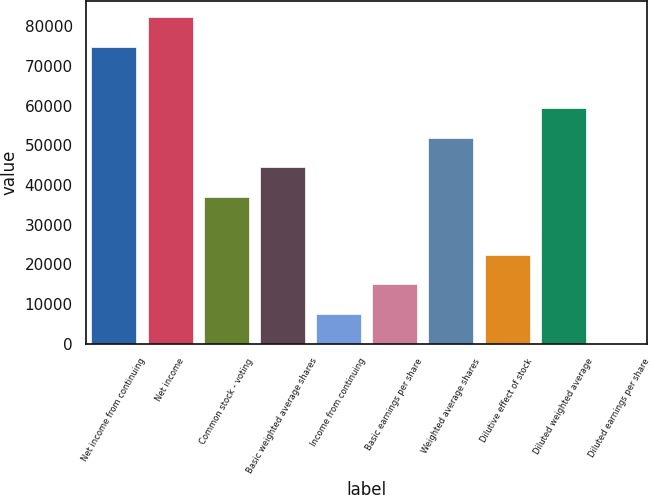<chart> <loc_0><loc_0><loc_500><loc_500><bar_chart><fcel>Net income from continuing<fcel>Net income<fcel>Common stock - voting<fcel>Basic weighted average shares<fcel>Income from continuing<fcel>Basic earnings per share<fcel>Weighted average shares<fcel>Dilutive effect of stock<fcel>Diluted weighted average<fcel>Diluted earnings per share<nl><fcel>74806<fcel>82286.4<fcel>36930<fcel>44410.4<fcel>7482.37<fcel>14962.8<fcel>51890.8<fcel>22443.2<fcel>59371.2<fcel>1.97<nl></chart> 